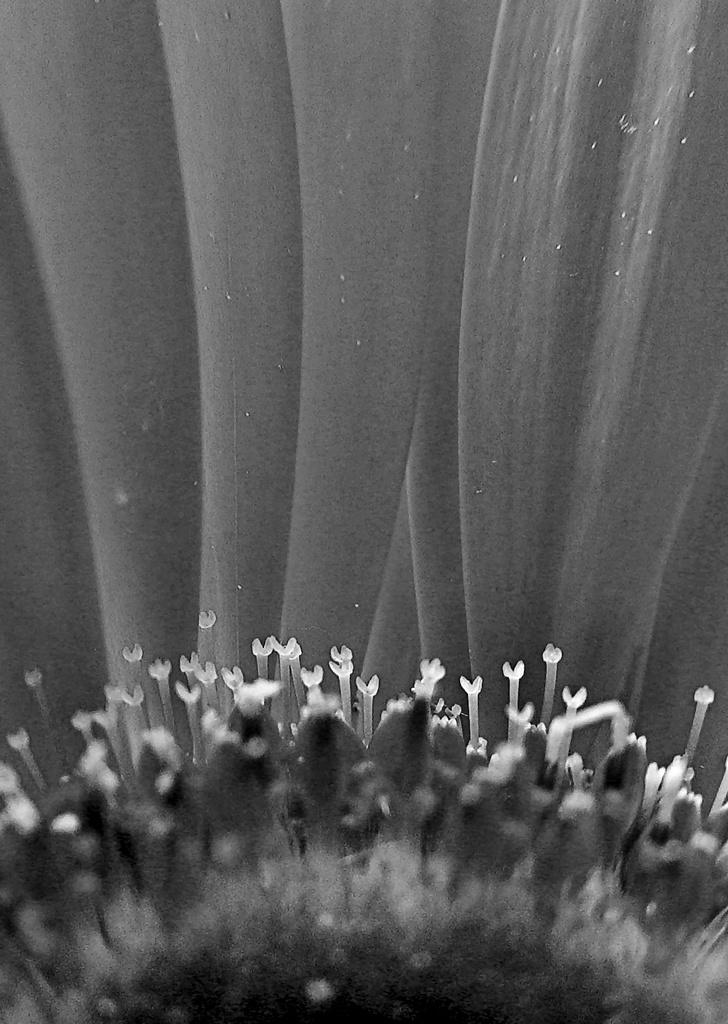What is the main subject of the image? There is a flower in the image. Can you describe any specific features of the flower? Yes, there are petals of a flower in the image. How many cattle can be seen grazing in the field in the image? There are no cattle present in the image; it features a flower with petals. What type of pot is visible in the image? There is no pot present in the image; it features a flower with petals. 